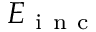<formula> <loc_0><loc_0><loc_500><loc_500>E _ { i n c }</formula> 